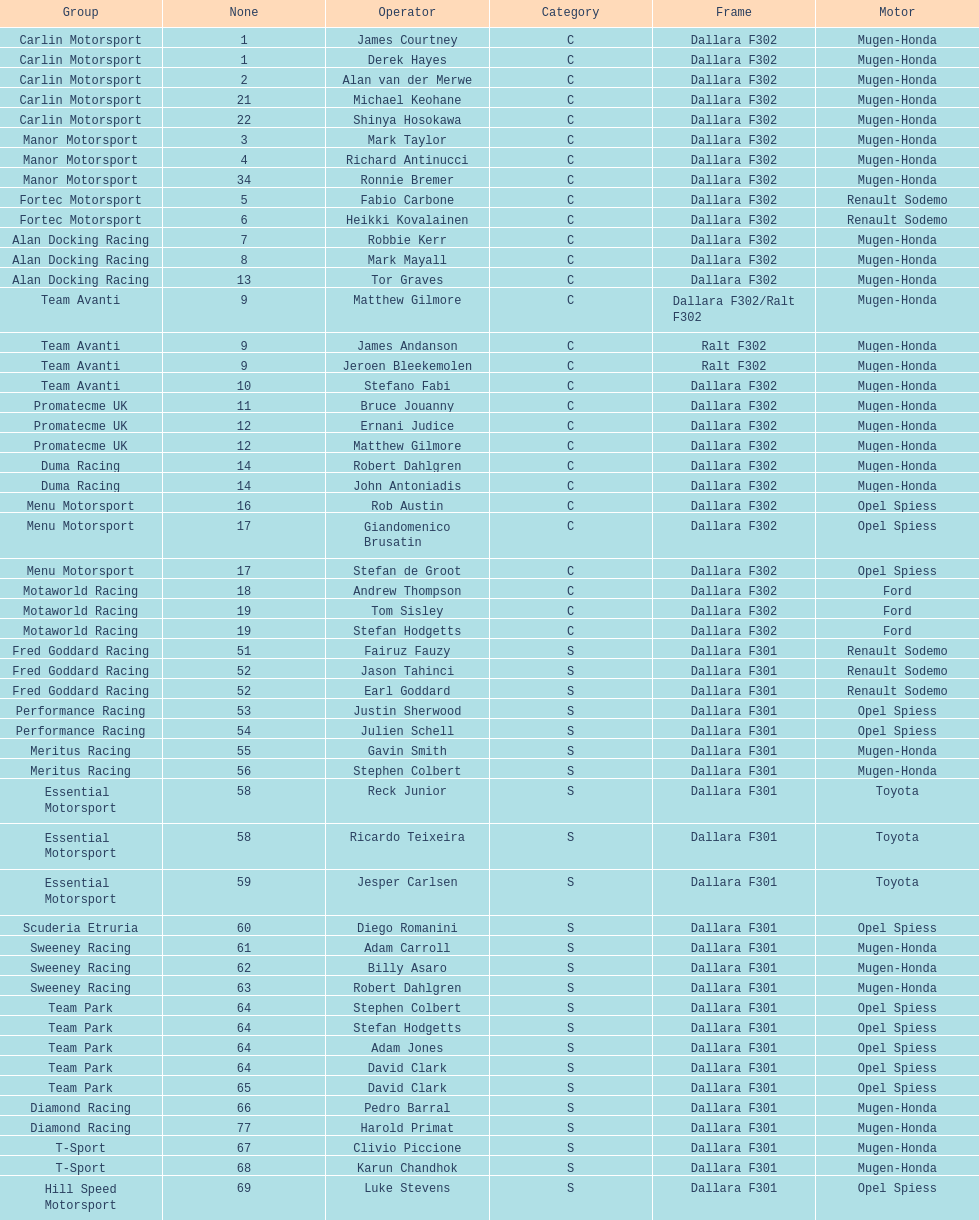What team is listed above diamond racing? Team Park. 